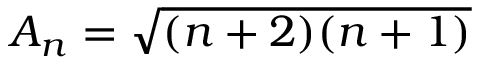Convert formula to latex. <formula><loc_0><loc_0><loc_500><loc_500>A _ { n } = \sqrt { ( n + 2 ) ( n + 1 ) }</formula> 